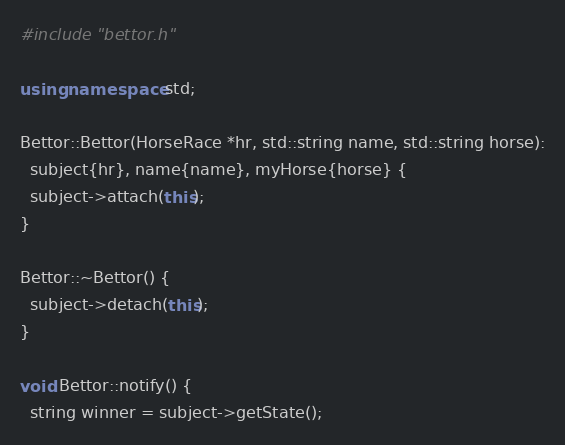Convert code to text. <code><loc_0><loc_0><loc_500><loc_500><_C++_>#include "bettor.h"

using namespace std;

Bettor::Bettor(HorseRace *hr, std::string name, std::string horse):
  subject{hr}, name{name}, myHorse{horse} {
  subject->attach(this);
}

Bettor::~Bettor() {
  subject->detach(this);
}

void Bettor::notify() {
  string winner = subject->getState();</code> 